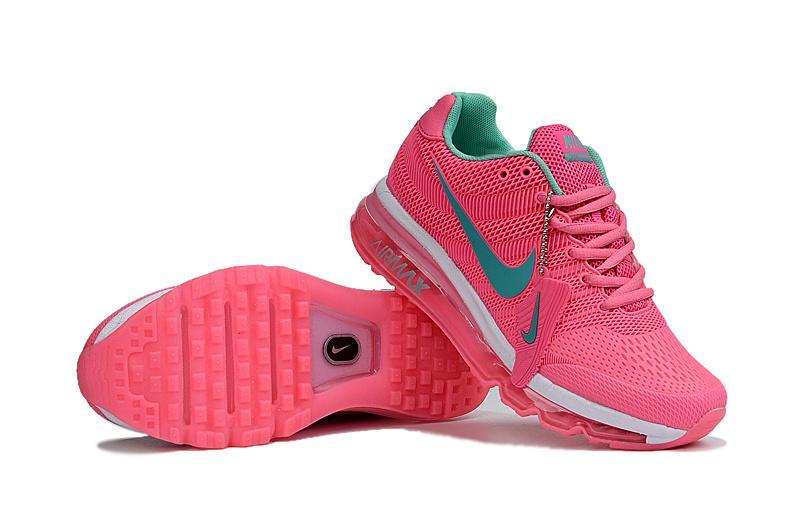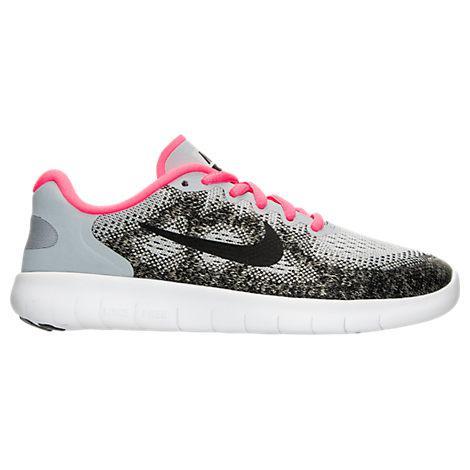The first image is the image on the left, the second image is the image on the right. Analyze the images presented: Is the assertion "A single shoe is shown in profile in each of the images." valid? Answer yes or no. No. The first image is the image on the left, the second image is the image on the right. Assess this claim about the two images: "Each image contains a single sneaker, and exactly one sneaker has pink laces.". Correct or not? Answer yes or no. No. 